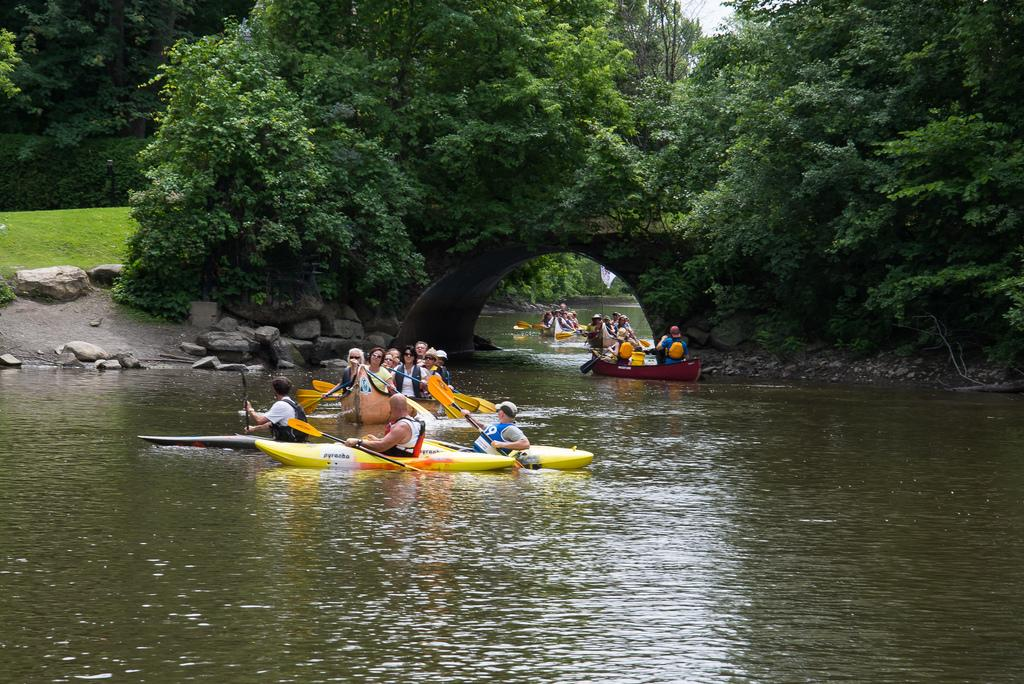What activity are the persons in the image engaged in? The persons in the image are surf boating in the water. What can be seen at the top of the image? There are trees on the top of the image. What type of vegetation is present on the ground in the background? There is grass on the ground in the background. What else can be seen in the background of the image? There are trees in the background. What type of garden can be seen in the image? There is no garden present in the image; it features persons surf boating in the water with trees and grass in the background. 